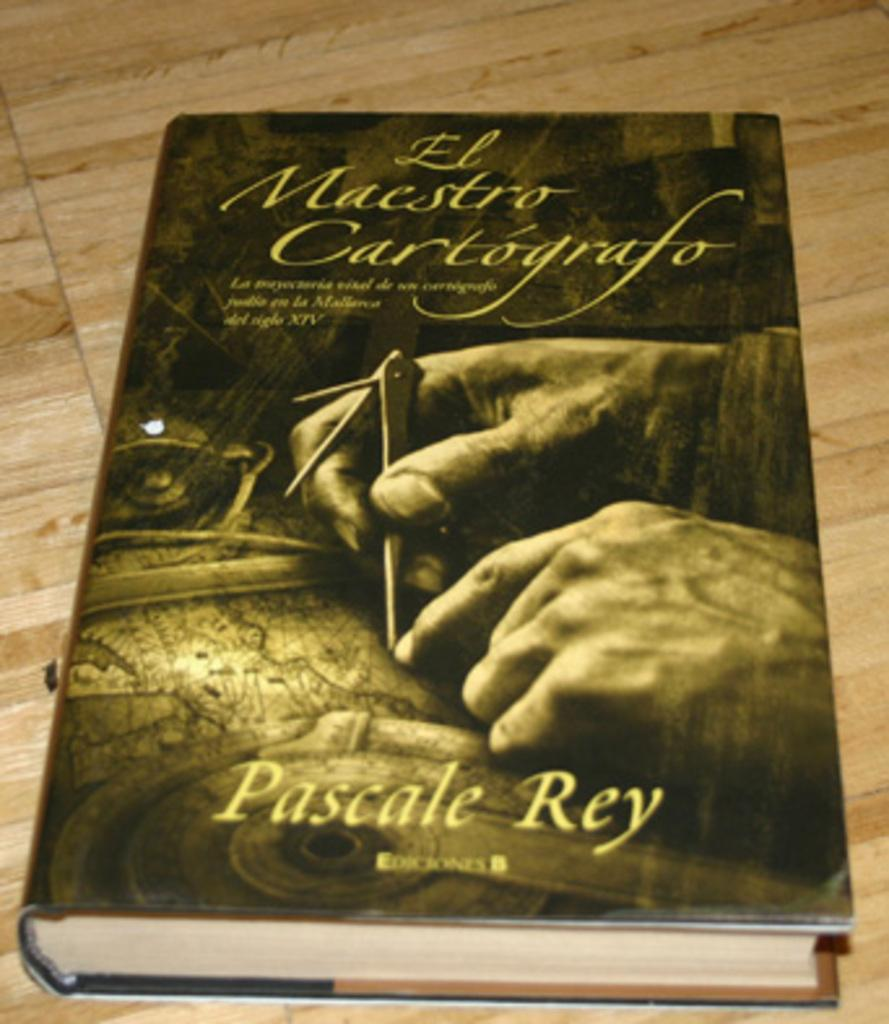<image>
Give a short and clear explanation of the subsequent image. A book called El Maestro Cartografo is written by Pascale Rey. 